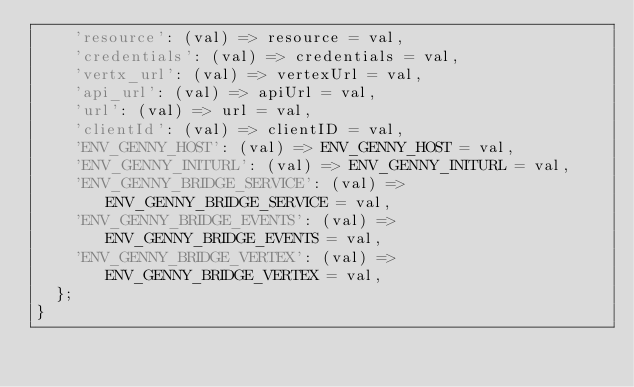Convert code to text. <code><loc_0><loc_0><loc_500><loc_500><_Dart_>    'resource': (val) => resource = val,
    'credentials': (val) => credentials = val,
    'vertx_url': (val) => vertexUrl = val,
    'api_url': (val) => apiUrl = val,
    'url': (val) => url = val,
    'clientId': (val) => clientID = val,
    'ENV_GENNY_HOST': (val) => ENV_GENNY_HOST = val,
    'ENV_GENNY_INITURL': (val) => ENV_GENNY_INITURL = val,
    'ENV_GENNY_BRIDGE_SERVICE': (val) => ENV_GENNY_BRIDGE_SERVICE = val,
    'ENV_GENNY_BRIDGE_EVENTS': (val) => ENV_GENNY_BRIDGE_EVENTS = val,
    'ENV_GENNY_BRIDGE_VERTEX': (val) => ENV_GENNY_BRIDGE_VERTEX = val,
  };
}
</code> 